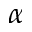<formula> <loc_0><loc_0><loc_500><loc_500>\alpha</formula> 